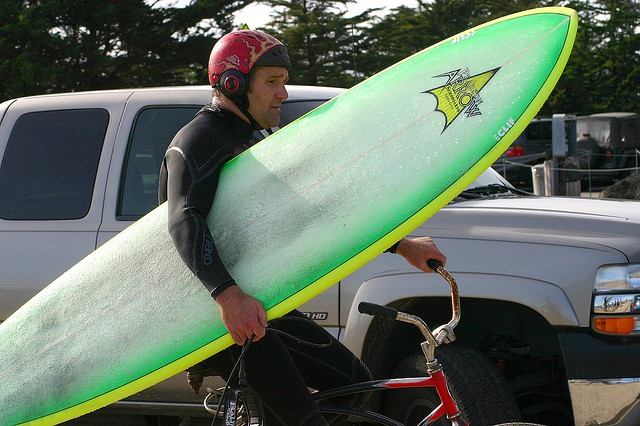Describe the objects in this image and their specific colors. I can see truck in black and gray tones, surfboard in black, darkgray, beige, and aquamarine tones, people in black, maroon, and gray tones, bicycle in black, gray, maroon, and darkgray tones, and car in black, maroon, gray, and navy tones in this image. 